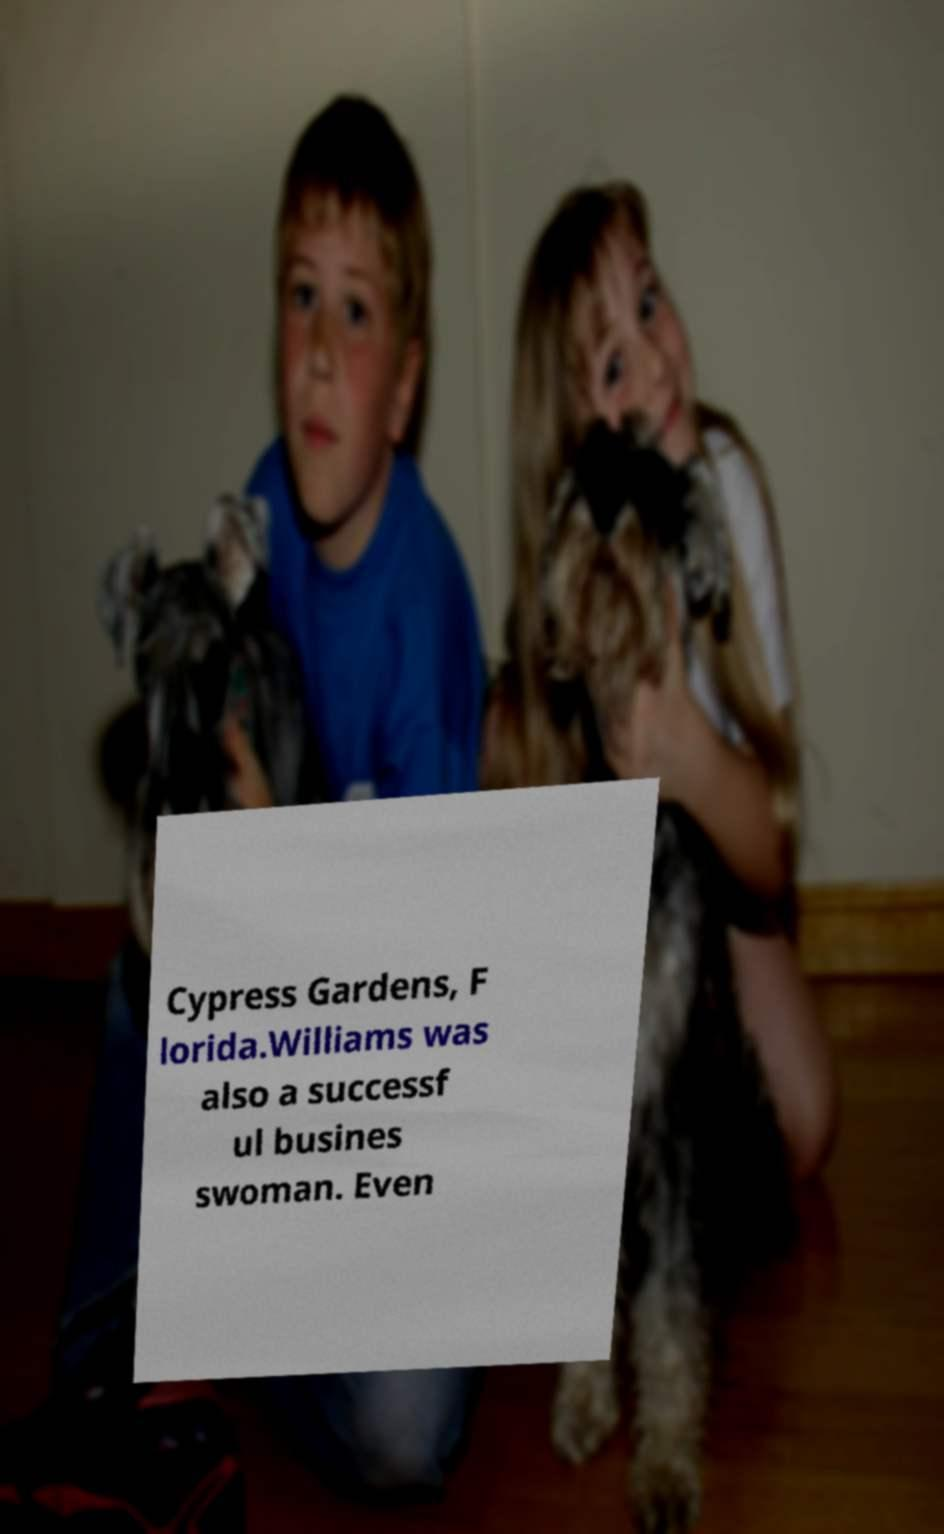Can you accurately transcribe the text from the provided image for me? Cypress Gardens, F lorida.Williams was also a successf ul busines swoman. Even 